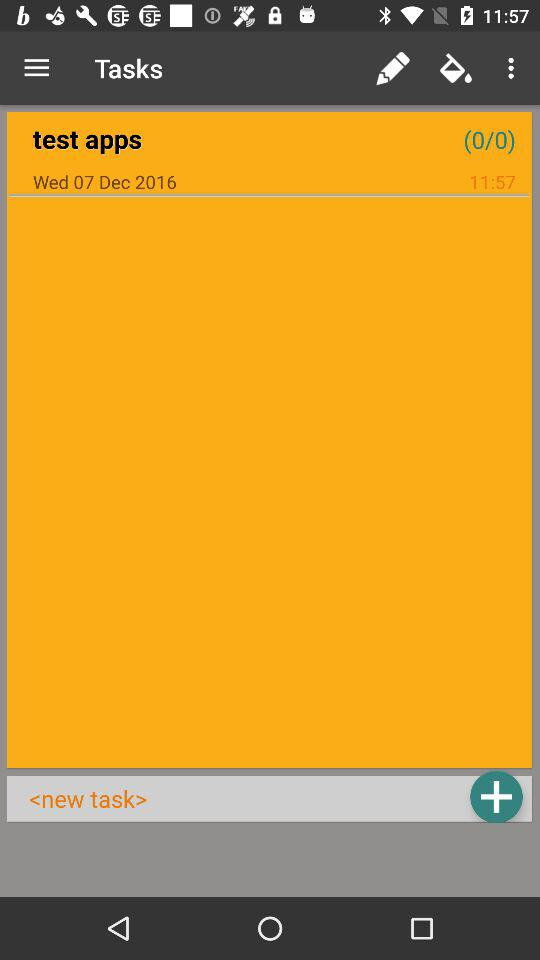How many times is the number 0 repeated in the text '(0/0)'?
Answer the question using a single word or phrase. 2 